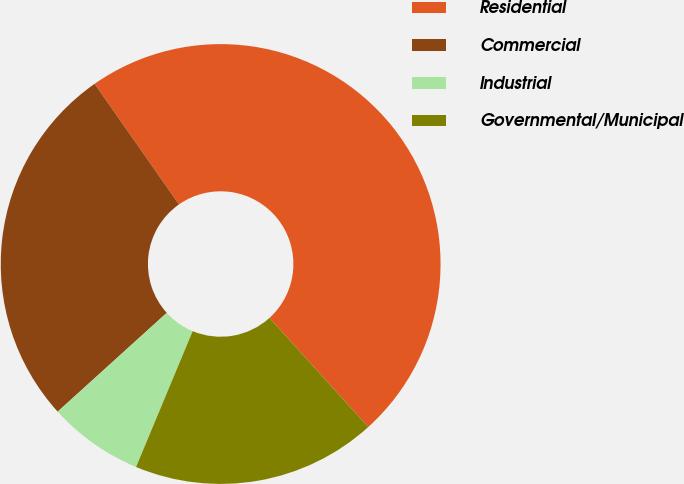<chart> <loc_0><loc_0><loc_500><loc_500><pie_chart><fcel>Residential<fcel>Commercial<fcel>Industrial<fcel>Governmental/Municipal<nl><fcel>48.0%<fcel>27.0%<fcel>7.0%<fcel>18.0%<nl></chart> 